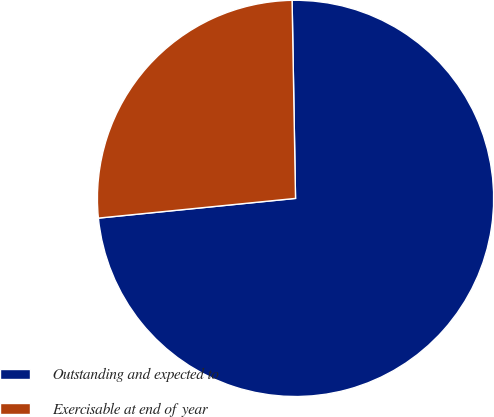<chart> <loc_0><loc_0><loc_500><loc_500><pie_chart><fcel>Outstanding and expected to<fcel>Exercisable at end of year<nl><fcel>73.69%<fcel>26.31%<nl></chart> 